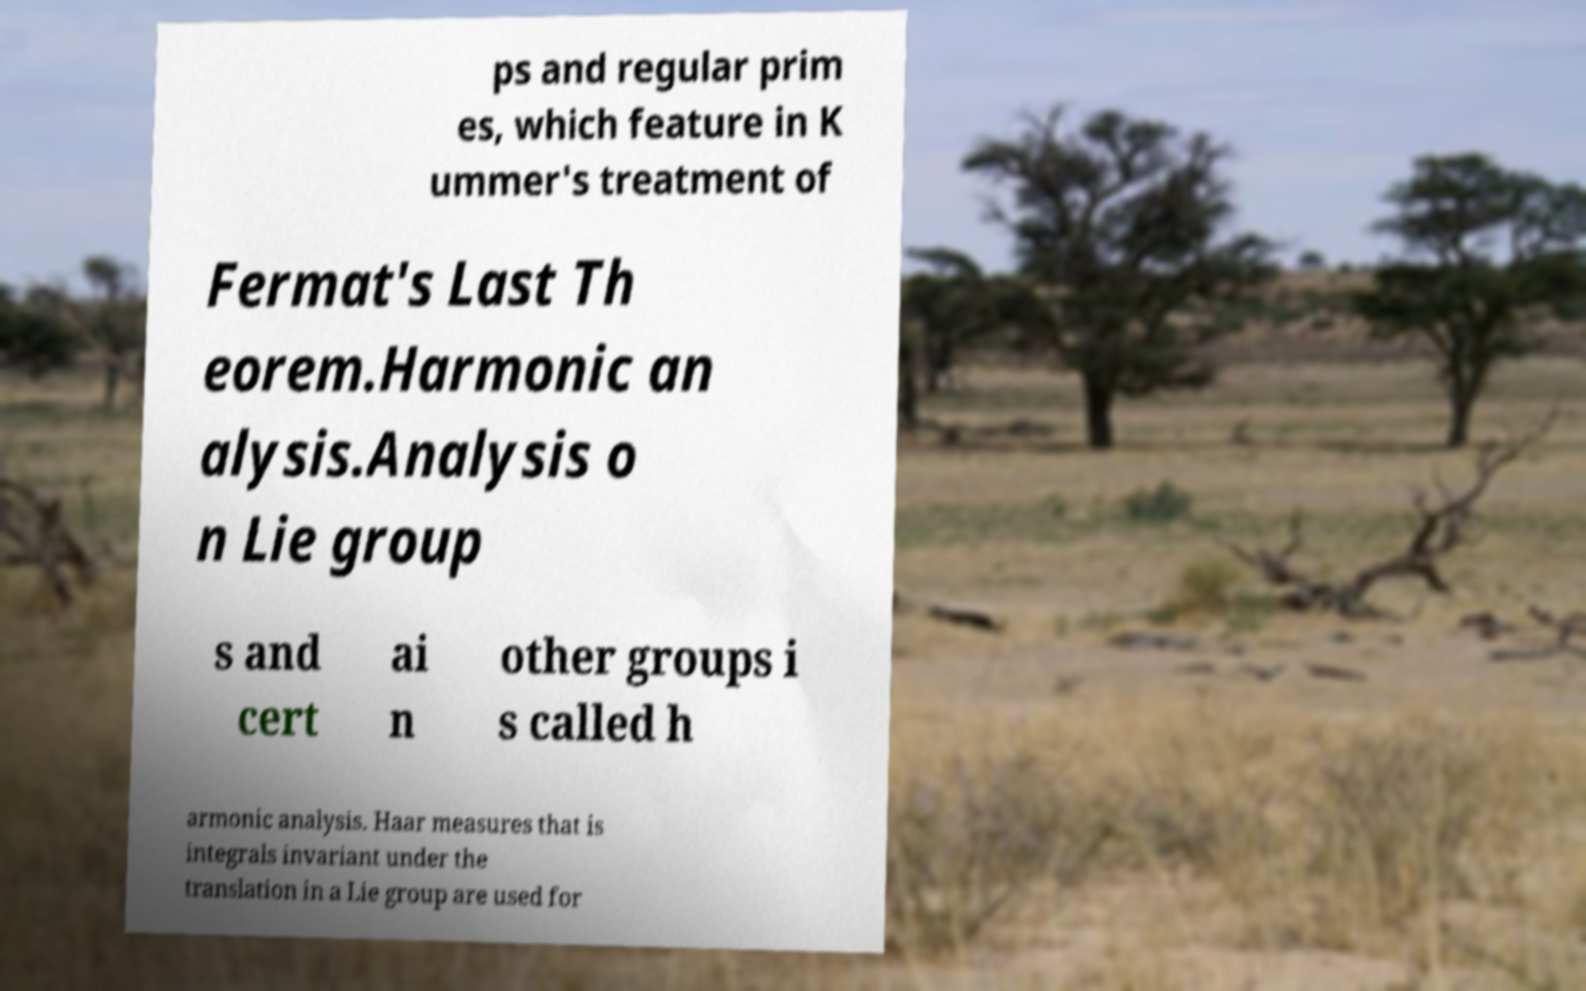For documentation purposes, I need the text within this image transcribed. Could you provide that? ps and regular prim es, which feature in K ummer's treatment of Fermat's Last Th eorem.Harmonic an alysis.Analysis o n Lie group s and cert ai n other groups i s called h armonic analysis. Haar measures that is integrals invariant under the translation in a Lie group are used for 